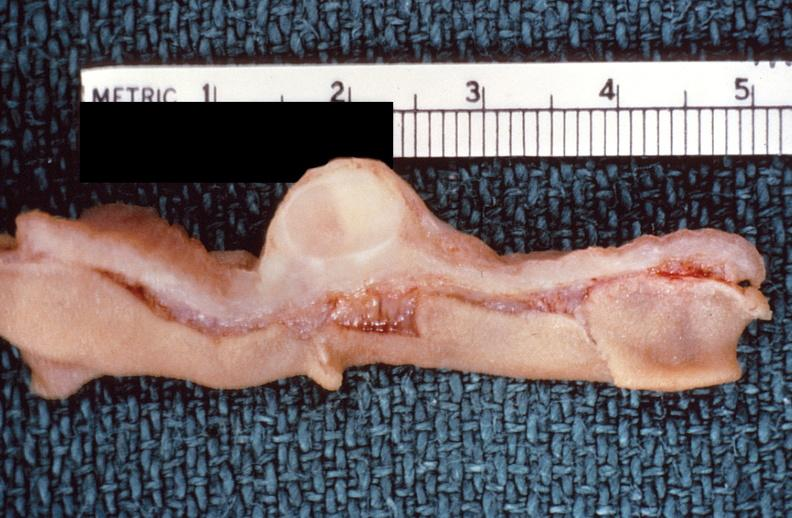what is present?
Answer the question using a single word or phrase. Gastrointestinal 